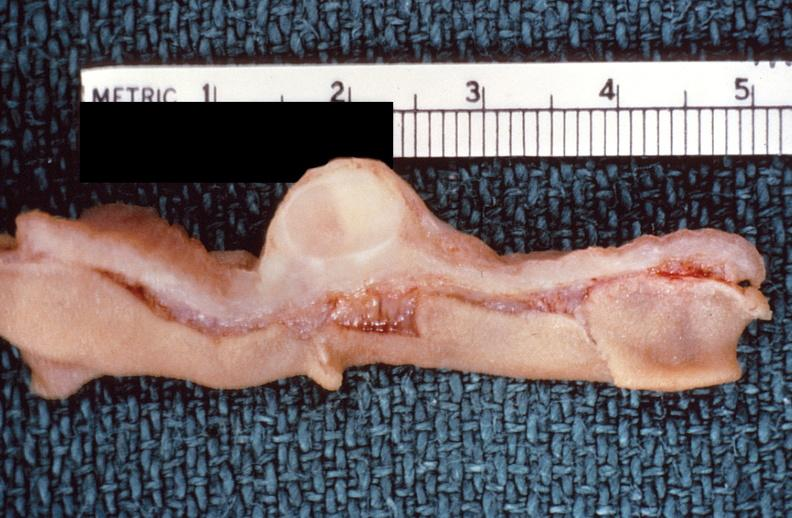what is present?
Answer the question using a single word or phrase. Gastrointestinal 